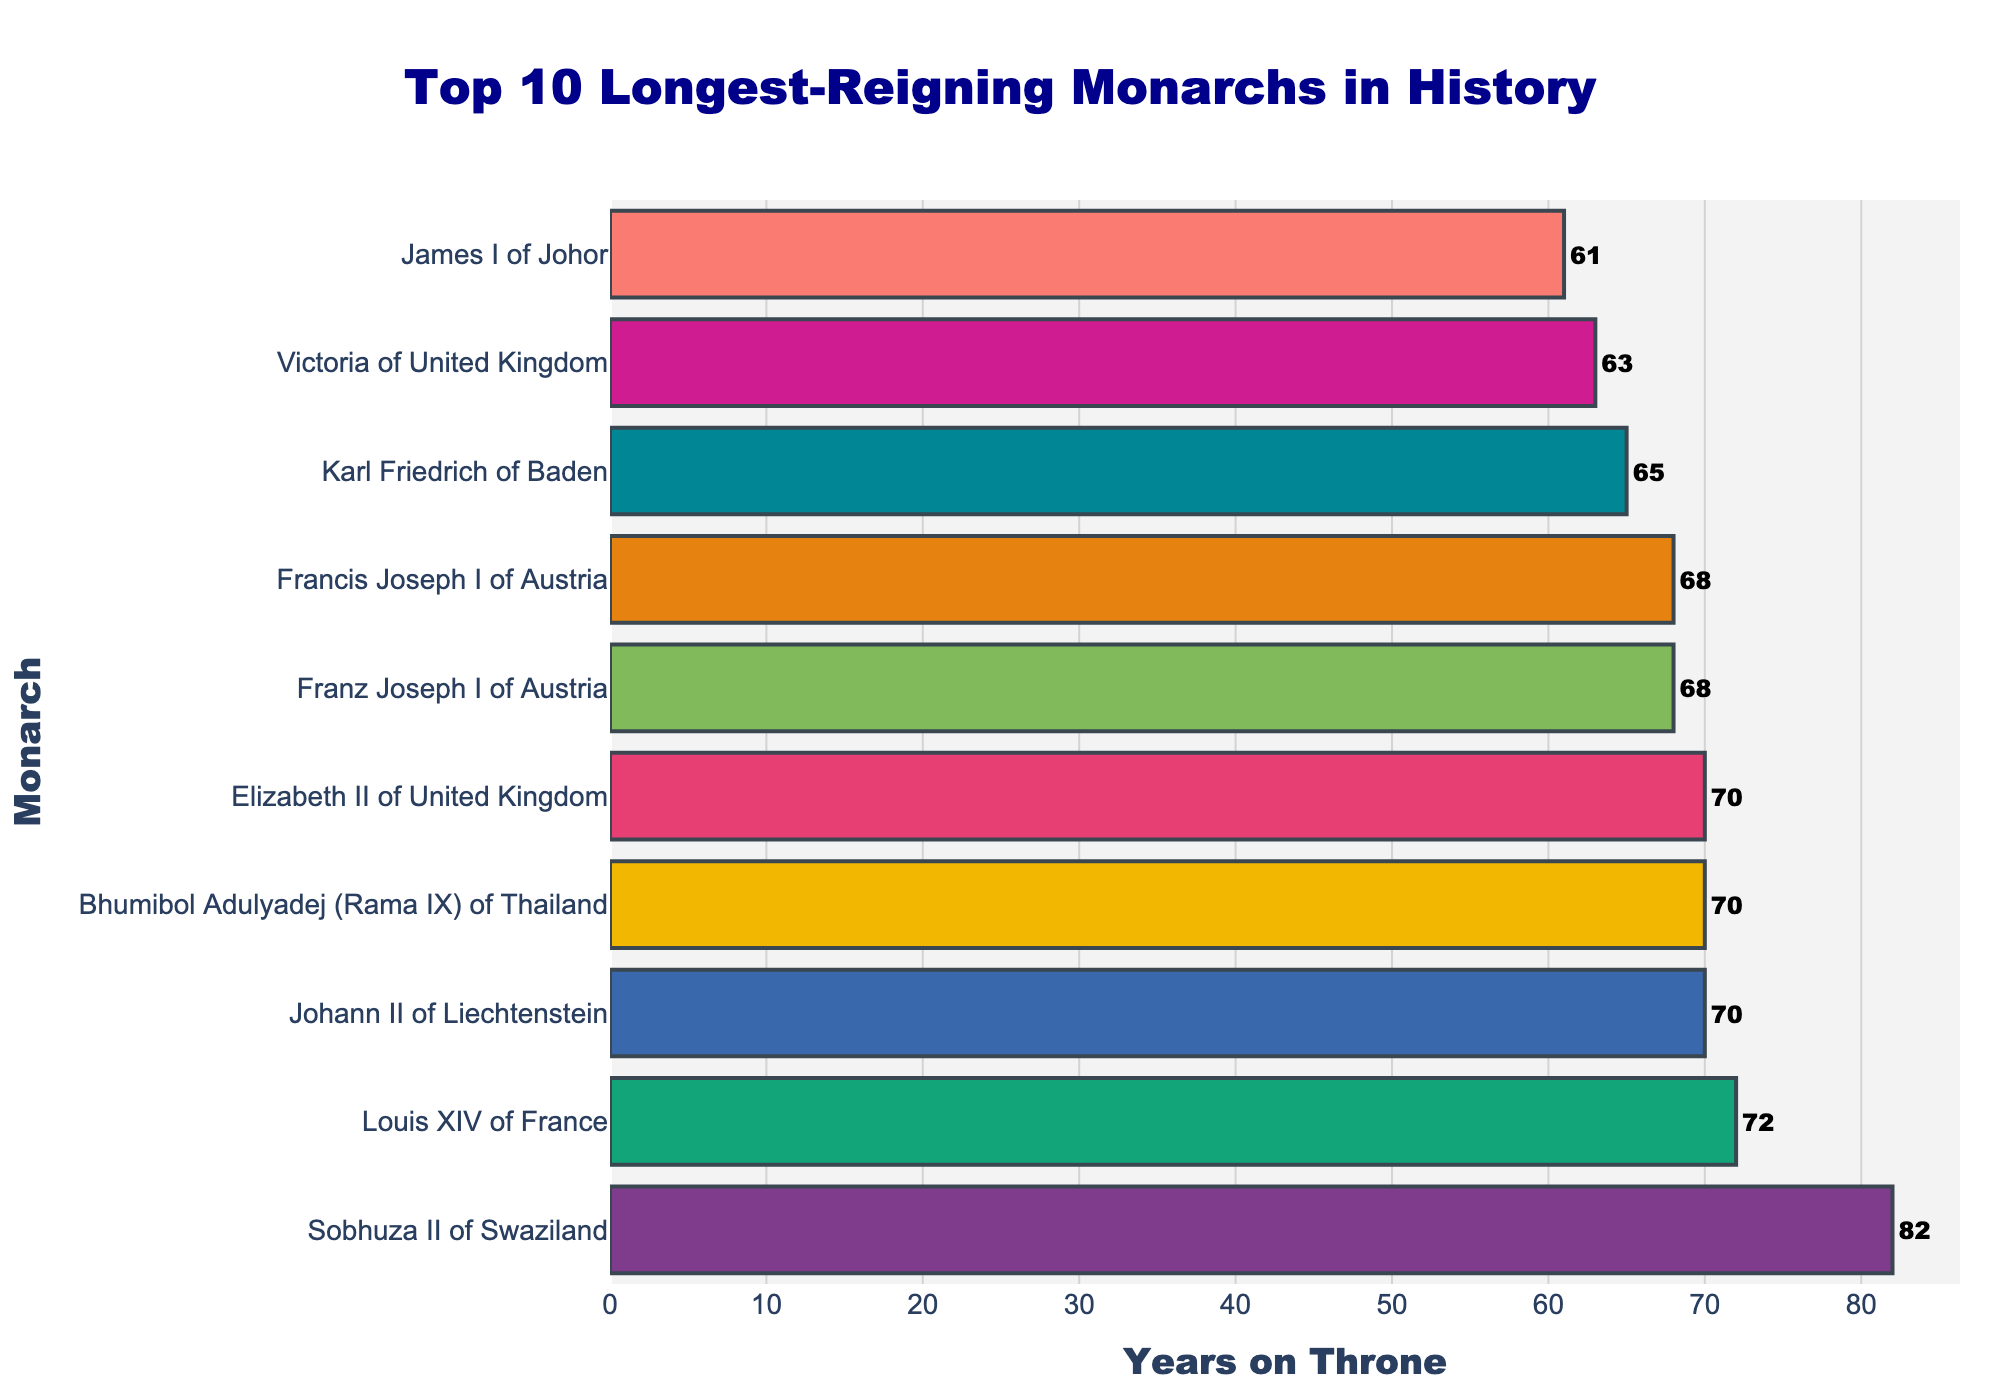Who is the longest-reigning monarch in history according to the chart? The longest-reigning monarch in the chart can be identified by looking at the bar that extends the furthest to the right. In this case, it's Sobhuza II of Swaziland.
Answer: Sobhuza II of Swaziland How many years did Queen Elizabeth II of the United Kingdom reign? Find the bar labeled "Elizabeth II of United Kingdom" and note the value at the end of the bar. The value is 70 years.
Answer: 70 years Who reigned longer: Victoria of the United Kingdom or Franz Joseph I of Austria? By how many years? Compare the lengths of the bars for Victoria of the United Kingdom (63 years) and Franz Joseph I of Austria (68 years). Subtract Victoria's years from Franz Joseph's years. 68 - 63 = 5 years.
Answer: Franz Joseph I of Austria by 5 years What is the total number of years on the throne for the top 3 longest-reigning monarchs? Sum the years on the throne for the top 3 longest-reigning monarchs: Sobhuza II of Swaziland (82 years), Louis XIV of France (72 years), and Bhumibol Adulyadej (Rama IX) of Thailand (70 years). 82 + 72 + 70 = 224 years.
Answer: 224 years Which monarchs reigned for exactly 70 years, and name the countries they ruled? Identify the bars that reach 70 years: Bhumibol Adulyadej (Rama IX) of Thailand, Johann II of Liechtenstein, and Elizabeth II of the United Kingdom.
Answer: Bhumibol Adulyadej (Rama IX) of Thailand, Johann II of Liechtenstein, Elizabeth II of the United Kingdom What is the average length of reign for the top 10 longest-reigning monarchs? Add the lengths of reigns for all top 10 monarchs: 82, 72, 70, 70, 68, 68, 65, 63, 61, 59. Then divide by 10. (82 + 72 + 70 + 70 + 68 + 68 + 65 + 63 + 61 + 59) / 10 = 67.8 years.
Answer: 67.8 years Which monarch reigned the shortest among the top 10, and how many years did they reign? Look for the shortest bar among the top 10 longest reigns. The shortest bar is for George III of the United Kingdom, with 59 years on the throne.
Answer: George III of the United Kingdom, 59 years List two monarchs whose reign lengths are the same and mention how many years each reigned. Identify bars with equal lengths: Bhumibol Adulyadej (Rama IX) of Thailand and Elizabeth II of the United Kingdom both reigned for 70 years; Franz Joseph I of Austria and Francis Joseph I of Austria both reigned for 68 years.
Answer: Bhumibol Adulyadej (Rama IX) of Thailand and Elizabeth II of the United Kingdom: 70 years; Franz Joseph I of Austria and Francis Joseph I of Austria: 68 years How much longer did Sobhuza II of Swaziland reign compared to Constantine VIII of the Byzantine Empire? Subtract the years on the throne of Constantine VIII (57 years) from Sobhuza II (82 years). 82 - 57 = 25 years.
Answer: 25 years 